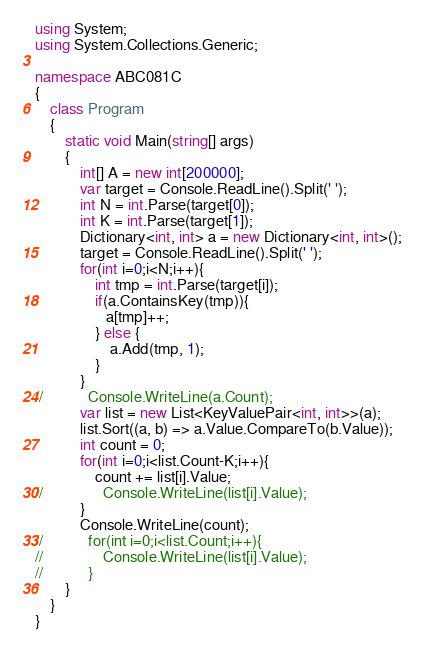Convert code to text. <code><loc_0><loc_0><loc_500><loc_500><_C#_>using System;
using System.Collections.Generic;

namespace ABC081C
{
    class Program
    {
        static void Main(string[] args)
        {
            int[] A = new int[200000];
            var target = Console.ReadLine().Split(' ');
            int N = int.Parse(target[0]);
            int K = int.Parse(target[1]);
            Dictionary<int, int> a = new Dictionary<int, int>(); 
            target = Console.ReadLine().Split(' ');
            for(int i=0;i<N;i++){
                int tmp = int.Parse(target[i]);
                if(a.ContainsKey(tmp)){
                   a[tmp]++; 
                } else {
                    a.Add(tmp, 1);
                }
            }
//            Console.WriteLine(a.Count);
            var list = new List<KeyValuePair<int, int>>(a);
            list.Sort((a, b) => a.Value.CompareTo(b.Value));
            int count = 0;
            for(int i=0;i<list.Count-K;i++){
                count += list[i].Value;
//                Console.WriteLine(list[i].Value);
            }
            Console.WriteLine(count);
//            for(int i=0;i<list.Count;i++){
//                Console.WriteLine(list[i].Value);
//            }
        }
    }
}
</code> 